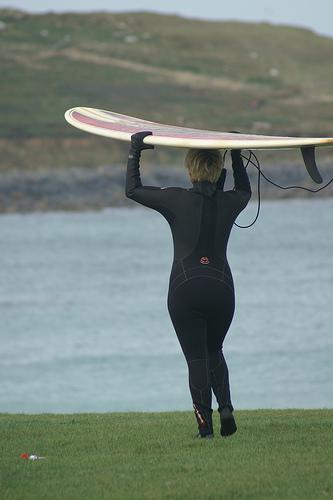Question: how many people are pictured here?
Choices:
A. Three.
B. 2.
C. One.
D. 5.
Answer with the letter. Answer: C Question: where was this picture likely taken?
Choices:
A. At the beach.
B. The ocean.
C. At school.
D. At home.
Answer with the letter. Answer: B Question: what color surfboard is the woman holding here?
Choices:
A. Yellow.
B. White.
C. Pink.
D. Black.
Answer with the letter. Answer: B Question: what color is the ground shown here?
Choices:
A. Brown.
B. Green.
C. Black.
D. Red.
Answer with the letter. Answer: B Question: what color is the sky in this photo?
Choices:
A. White.
B. Black.
C. Blue.
D. Grey.
Answer with the letter. Answer: C 